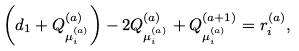Convert formula to latex. <formula><loc_0><loc_0><loc_500><loc_500>\left ( d _ { 1 } + Q ^ { ( a ) } _ { \mu ^ { ( a ) } _ { i } } \right ) - 2 Q ^ { ( a ) } _ { \mu ^ { ( a ) } _ { i } } + Q ^ { ( a + 1 ) } _ { \mu ^ { ( a ) } _ { i } } = r _ { i } ^ { ( a ) } ,</formula> 